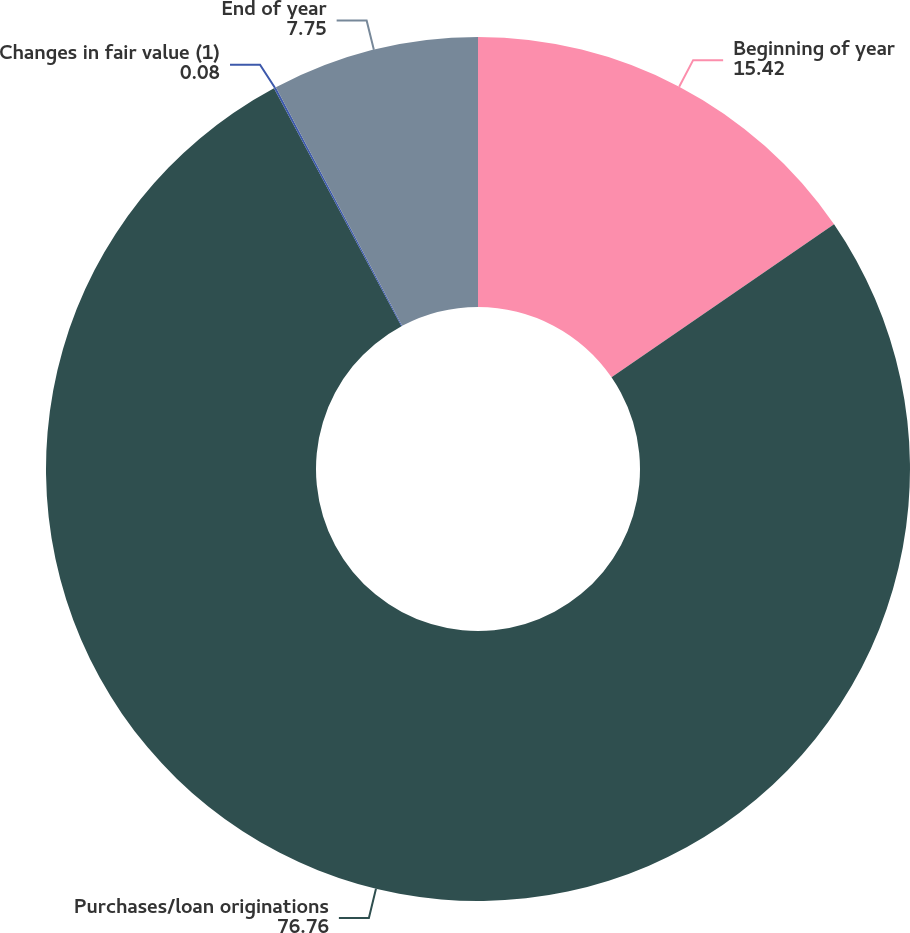Convert chart. <chart><loc_0><loc_0><loc_500><loc_500><pie_chart><fcel>Beginning of year<fcel>Purchases/loan originations<fcel>Changes in fair value (1)<fcel>End of year<nl><fcel>15.42%<fcel>76.76%<fcel>0.08%<fcel>7.75%<nl></chart> 